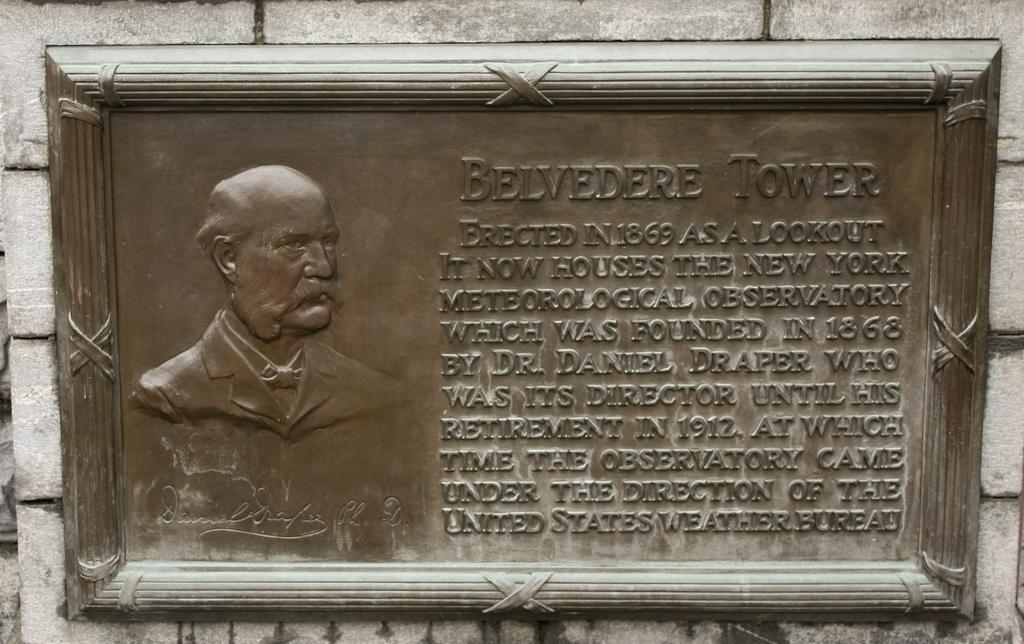What is the main subject in the image? There is a frame in the image. Where is the frame located? The frame is placed on a wall. What type of seed can be seen growing inside the frame in the image? There is no seed present inside the frame in the image. 